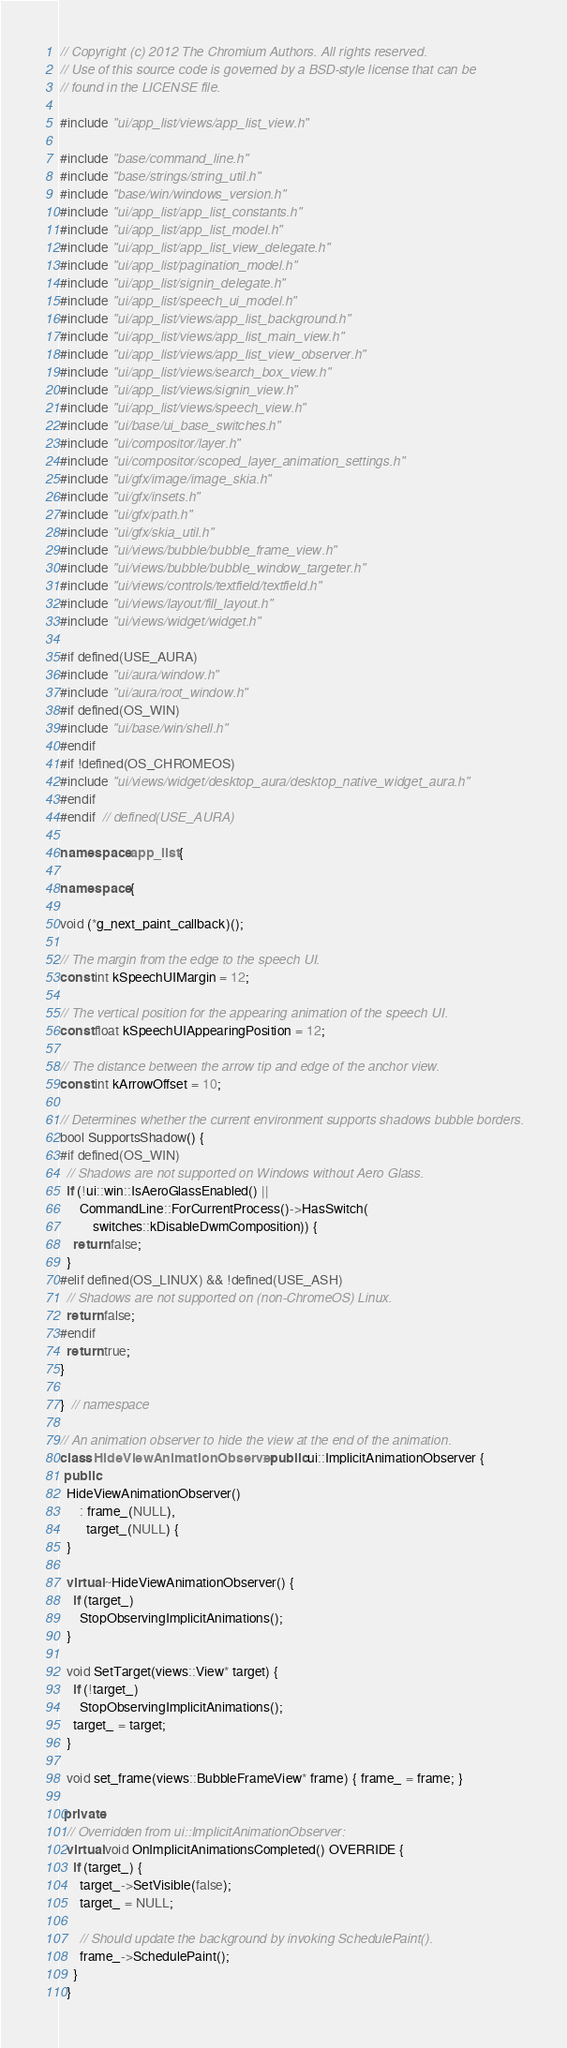Convert code to text. <code><loc_0><loc_0><loc_500><loc_500><_C++_>// Copyright (c) 2012 The Chromium Authors. All rights reserved.
// Use of this source code is governed by a BSD-style license that can be
// found in the LICENSE file.

#include "ui/app_list/views/app_list_view.h"

#include "base/command_line.h"
#include "base/strings/string_util.h"
#include "base/win/windows_version.h"
#include "ui/app_list/app_list_constants.h"
#include "ui/app_list/app_list_model.h"
#include "ui/app_list/app_list_view_delegate.h"
#include "ui/app_list/pagination_model.h"
#include "ui/app_list/signin_delegate.h"
#include "ui/app_list/speech_ui_model.h"
#include "ui/app_list/views/app_list_background.h"
#include "ui/app_list/views/app_list_main_view.h"
#include "ui/app_list/views/app_list_view_observer.h"
#include "ui/app_list/views/search_box_view.h"
#include "ui/app_list/views/signin_view.h"
#include "ui/app_list/views/speech_view.h"
#include "ui/base/ui_base_switches.h"
#include "ui/compositor/layer.h"
#include "ui/compositor/scoped_layer_animation_settings.h"
#include "ui/gfx/image/image_skia.h"
#include "ui/gfx/insets.h"
#include "ui/gfx/path.h"
#include "ui/gfx/skia_util.h"
#include "ui/views/bubble/bubble_frame_view.h"
#include "ui/views/bubble/bubble_window_targeter.h"
#include "ui/views/controls/textfield/textfield.h"
#include "ui/views/layout/fill_layout.h"
#include "ui/views/widget/widget.h"

#if defined(USE_AURA)
#include "ui/aura/window.h"
#include "ui/aura/root_window.h"
#if defined(OS_WIN)
#include "ui/base/win/shell.h"
#endif
#if !defined(OS_CHROMEOS)
#include "ui/views/widget/desktop_aura/desktop_native_widget_aura.h"
#endif
#endif  // defined(USE_AURA)

namespace app_list {

namespace {

void (*g_next_paint_callback)();

// The margin from the edge to the speech UI.
const int kSpeechUIMargin = 12;

// The vertical position for the appearing animation of the speech UI.
const float kSpeechUIAppearingPosition = 12;

// The distance between the arrow tip and edge of the anchor view.
const int kArrowOffset = 10;

// Determines whether the current environment supports shadows bubble borders.
bool SupportsShadow() {
#if defined(OS_WIN)
  // Shadows are not supported on Windows without Aero Glass.
  if (!ui::win::IsAeroGlassEnabled() ||
      CommandLine::ForCurrentProcess()->HasSwitch(
          switches::kDisableDwmComposition)) {
    return false;
  }
#elif defined(OS_LINUX) && !defined(USE_ASH)
  // Shadows are not supported on (non-ChromeOS) Linux.
  return false;
#endif
  return true;
}

}  // namespace

// An animation observer to hide the view at the end of the animation.
class HideViewAnimationObserver : public ui::ImplicitAnimationObserver {
 public:
  HideViewAnimationObserver()
      : frame_(NULL),
        target_(NULL) {
  }

  virtual ~HideViewAnimationObserver() {
    if (target_)
      StopObservingImplicitAnimations();
  }

  void SetTarget(views::View* target) {
    if (!target_)
      StopObservingImplicitAnimations();
    target_ = target;
  }

  void set_frame(views::BubbleFrameView* frame) { frame_ = frame; }

 private:
  // Overridden from ui::ImplicitAnimationObserver:
  virtual void OnImplicitAnimationsCompleted() OVERRIDE {
    if (target_) {
      target_->SetVisible(false);
      target_ = NULL;

      // Should update the background by invoking SchedulePaint().
      frame_->SchedulePaint();
    }
  }
</code> 